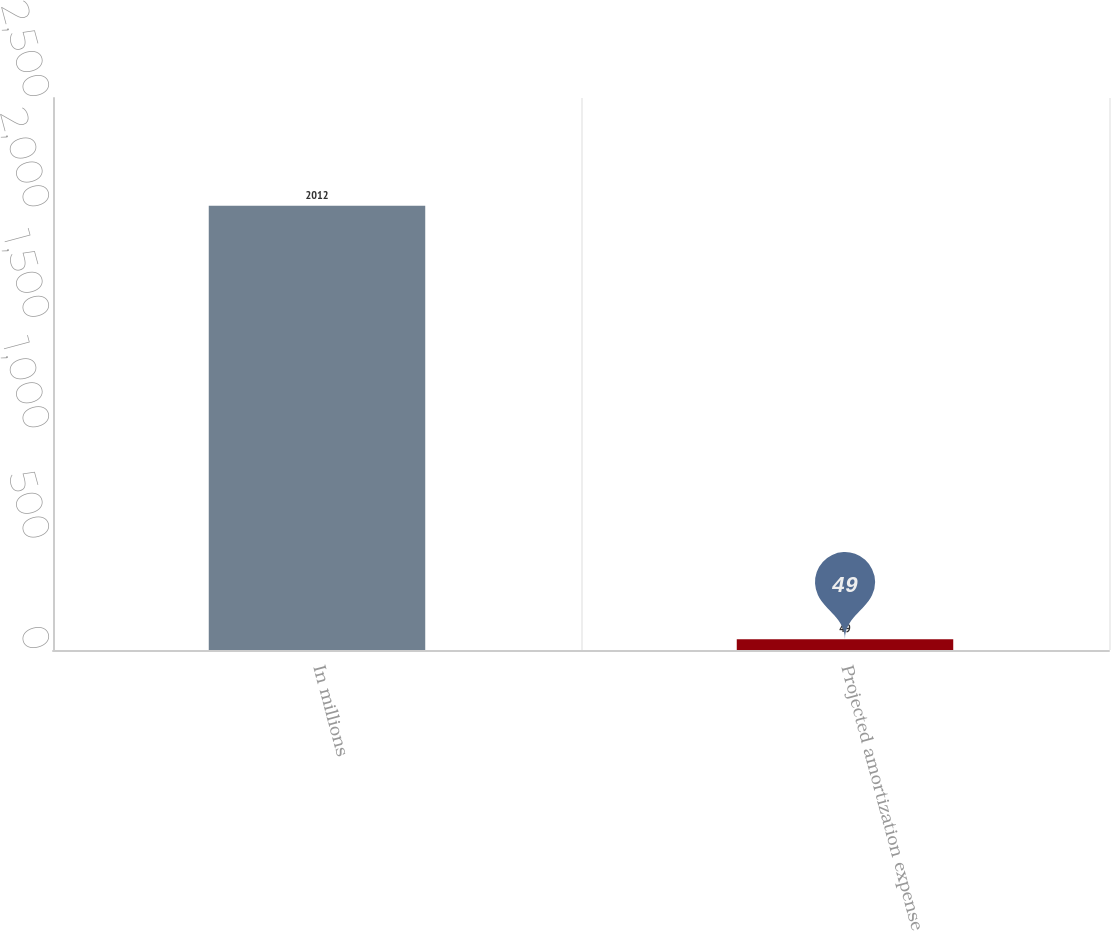Convert chart to OTSL. <chart><loc_0><loc_0><loc_500><loc_500><bar_chart><fcel>In millions<fcel>Projected amortization expense<nl><fcel>2012<fcel>49<nl></chart> 